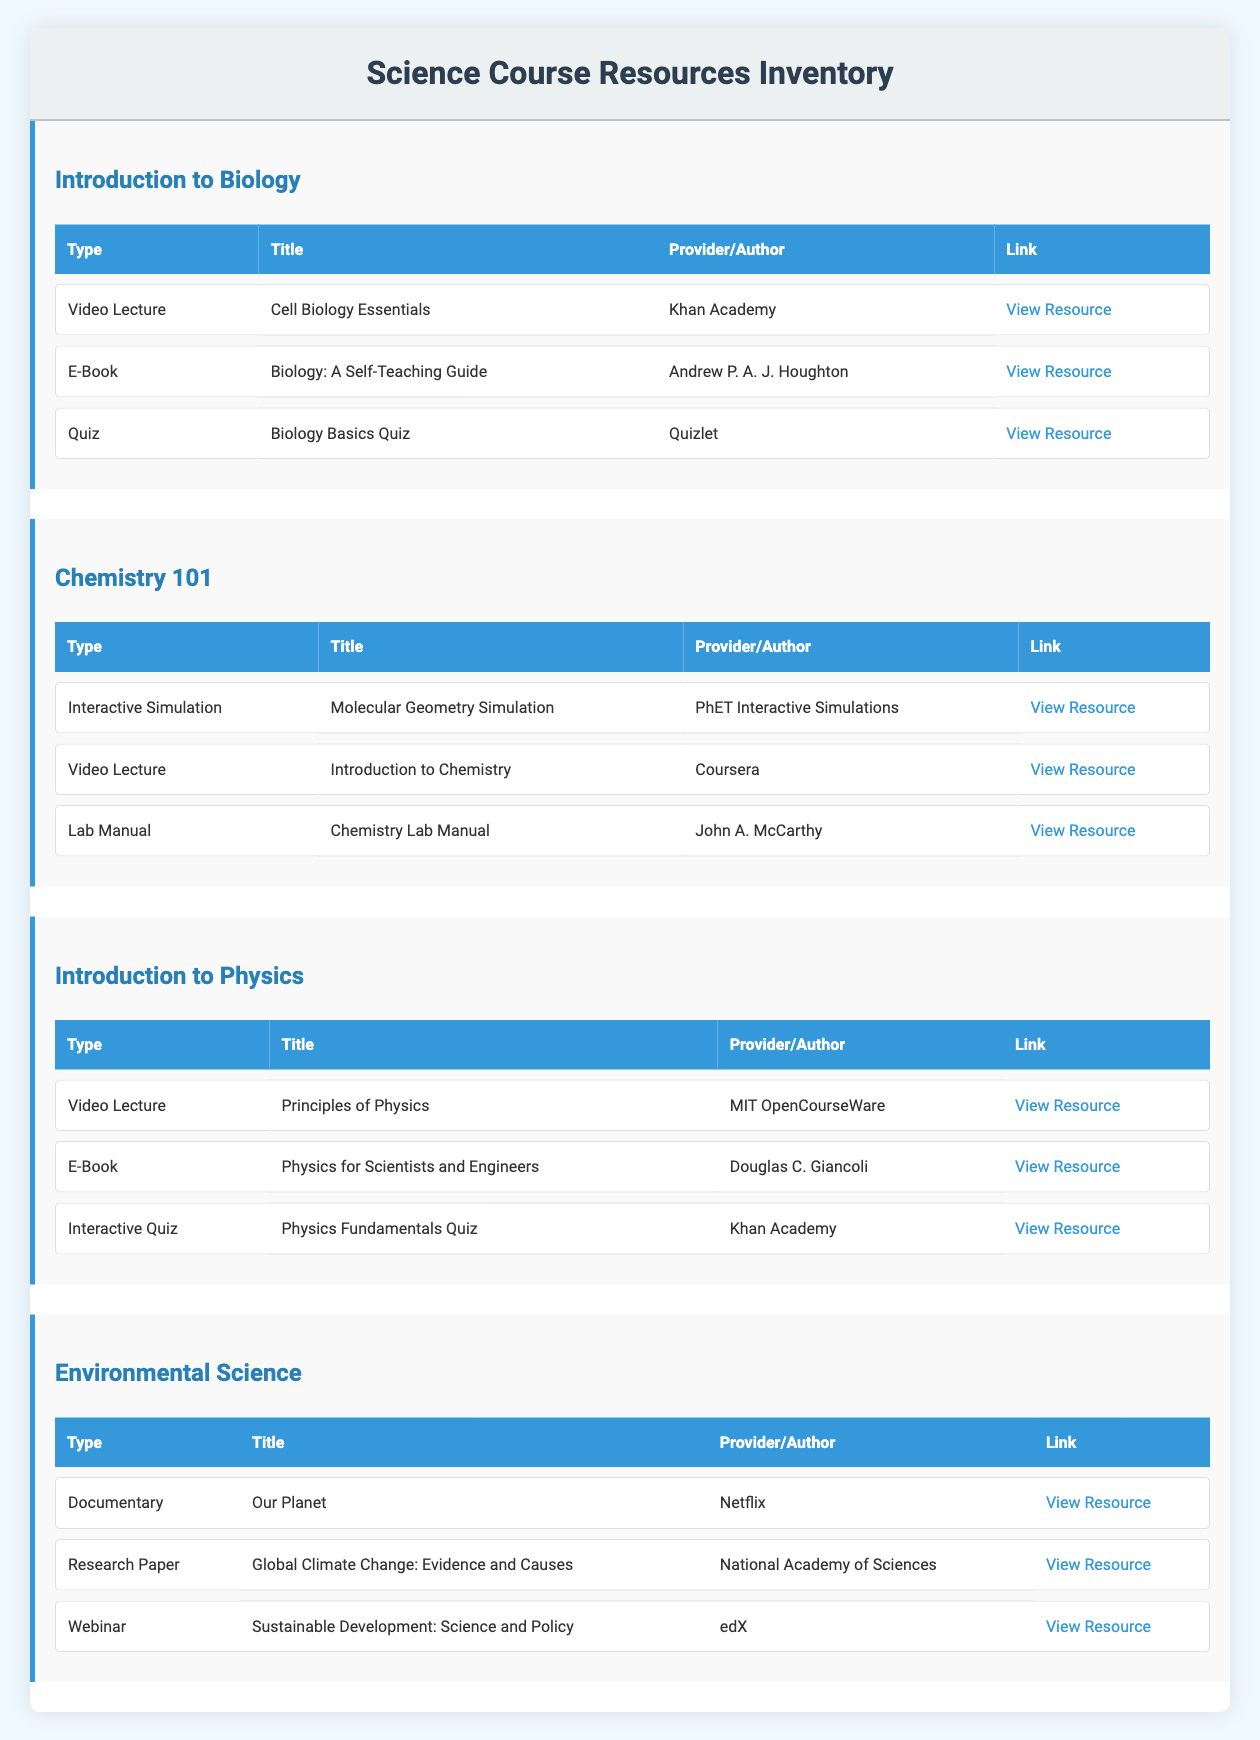What type of resource is available for the "Introduction to Biology" course? Based on the table, the resources for "Introduction to Biology" include a Video Lecture, an E-Book, and a Quiz.
Answer: Video Lecture, E-Book, Quiz Which provider offers the "Molecular Geometry Simulation"? The resource "Molecular Geometry Simulation" is provided by PhET Interactive Simulations.
Answer: PhET Interactive Simulations How many resources are listed for the "Environmental Science" course? There are three resources listed under "Environmental Science": a Documentary, a Research Paper, and a Webinar. Therefore, the total count is 3.
Answer: 3 Is there an E-Book available for "Chemistry 101"? A check of the resources for "Chemistry 101" shows that there is a Video Lecture, an Interactive Simulation, and a Lab Manual, but no E-Book is listed.
Answer: No Which course has a Quiz provided by Khan Academy? Looking through the table, the course "Introduction to Physics" includes a Quiz called "Physics Fundamentals Quiz" from Khan Academy, while "Introduction to Biology" has the "Biology Basics Quiz," also from Khan Academy. This indicates that both courses have quizzes from Khan Academy.
Answer: Introduction to Biology and Introduction to Physics What types of resources does the "Introduction to Physics" course have? The course "Introduction to Physics" has three types of resources: a Video Lecture, an E-Book, and an Interactive Quiz. Summing these resources, we observe it's structured this way: 1 Video Lecture, 1 E-Book, and 1 Interactive Quiz.
Answer: Video Lecture, E-Book, Interactive Quiz Which course has more than one resource type listed? After examining the table, both "Introduction to Biology," "Chemistry 101," "Introduction to Physics," and "Environmental Science" all feature multiple resource types. Thus, they all meet this criterion.
Answer: Yes, all courses listed have multiple resource types What is the total number of resources listed across all courses? Adding the number of resources for each course: Introduction to Biology (3) + Chemistry 101 (3) + Introduction to Physics (3) + Environmental Science (3) equals 12 resources in total.
Answer: 12 